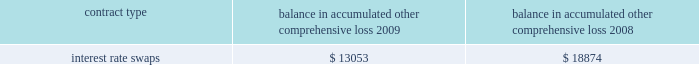The table below represents unrealized losses related to derivative amounts included in 201caccumulated other comprehensive loss 201d for the years ended december 31 , ( in thousands ) : balance in accumulated other comprehensive loss .
Note 9 2013 fair value measurements the company uses the fair value hierarchy , which prioritizes the inputs used to measure the fair value of certain of its financial instruments .
The hierarchy gives the highest priority to unadjusted quoted prices in active markets for identical assets or liabilities ( level 1 measurement ) and the lowest priority to unobservable inputs ( level 3 measurement ) .
The three levels of the fair value hierarchy are set forth below : 2022 level 1 2013 quoted prices are available in active markets for identical assets or liabilities as of the reporting date .
Active markets are those in which transactions for the asset or liability occur in sufficient frequency and volume to provide pricing information on an ongoing basis .
2022 level 2 2013 pricing inputs are other than quoted prices in active markets included in level 1 , which are either directly or indirectly observable as of the reporting date .
Level 2 includes those financial instruments that are valued using models or other valuation methodologies .
These models are primarily industry-standard models that consider various assumptions , including time value , volatility factors , and current market and contractual prices for the underlying instruments , as well as other relevant economic measures .
Substantially all of these assumptions are observable in the marketplace throughout the full term of the instrument , can be derived from observable data or are supported by observable levels at which transactions are executed in the marketplace .
2022 level 3 2013 pricing inputs include significant inputs that are generally less observable from objective sources .
These inputs may be used with internally developed methodologies that result in management 2019s best estimate of fair value from the perspective of a market participant .
The fair value of the interest rate swap transactions are based on the discounted net present value of the swap using third party quotes ( level 2 ) .
Changes in fair market value are recorded in other comprehensive income ( loss ) , and changes resulting from ineffectiveness are recorded in current earnings .
Assets and liabilities measured at fair value are based on one or more of three valuation techniques .
The three valuation techniques are identified in the table below and are as follows : a ) market approach 2013 prices and other relevant information generated by market transactions involving identical or comparable assets or liabilities b ) cost approach 2013 amount that would be required to replace the service capacity of an asset ( replacement cost ) c ) income approach 2013 techniques to convert future amounts to a single present amount based on market expectations ( including present value techniques , option-pricing and excess earnings models ) .
What is the net change in the balance of accumulated other comprehensive loss from 2008 to 2009? 
Computations: (13053 - 18874)
Answer: -5821.0. 